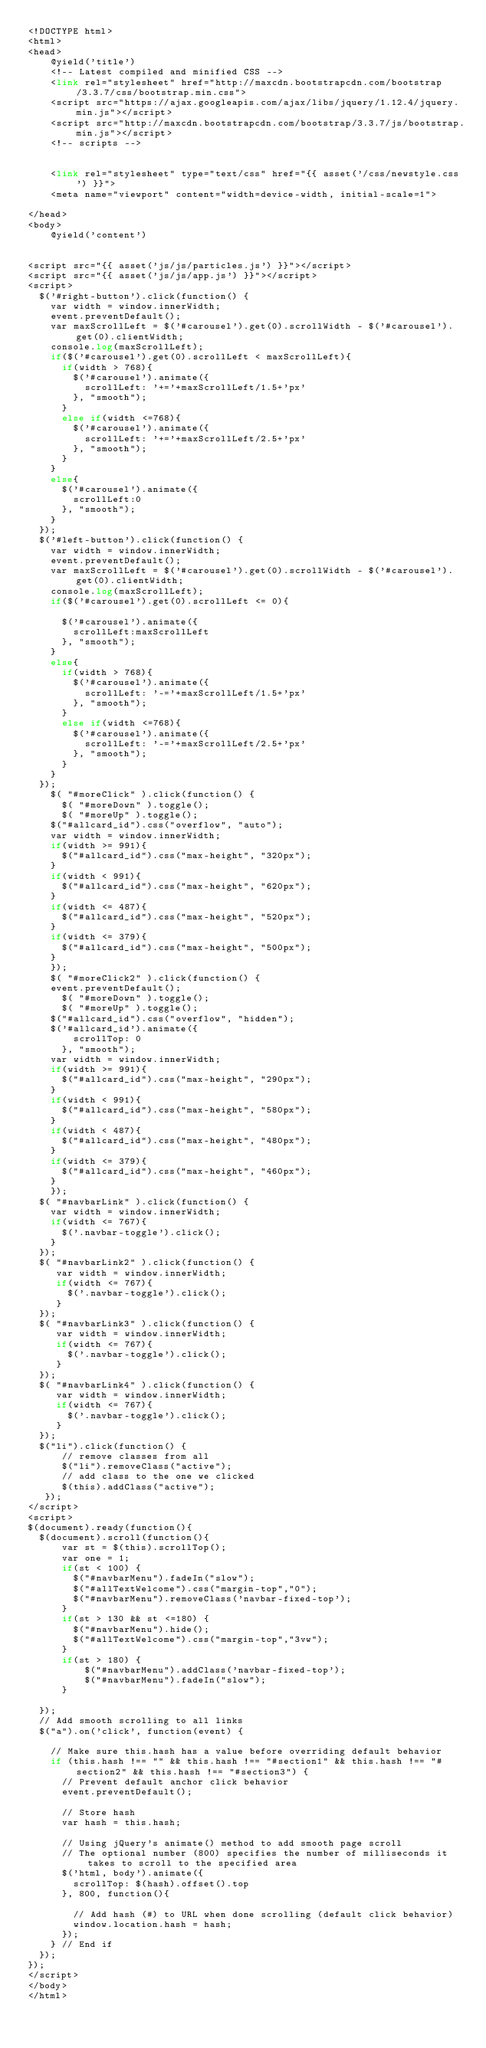Convert code to text. <code><loc_0><loc_0><loc_500><loc_500><_PHP_><!DOCTYPE html>
<html>
<head>
	@yield('title')
	<!-- Latest compiled and minified CSS -->
	<link rel="stylesheet" href="http://maxcdn.bootstrapcdn.com/bootstrap/3.3.7/css/bootstrap.min.css">
  	<script src="https://ajax.googleapis.com/ajax/libs/jquery/1.12.4/jquery.min.js"></script>
  	<script src="http://maxcdn.bootstrapcdn.com/bootstrap/3.3.7/js/bootstrap.min.js"></script>
  	<!-- scripts -->


	<link rel="stylesheet" type="text/css" href="{{ asset('/css/newstyle.css') }}">
	<meta name="viewport" content="width=device-width, initial-scale=1">

</head>
<body>
	@yield('content')


<script src="{{ asset('js/js/particles.js') }}"></script>
<script src="{{ asset('js/js/app.js') }}"></script>
<script>
  $('#right-button').click(function() {
    var width = window.innerWidth;
    event.preventDefault();
    var maxScrollLeft = $('#carousel').get(0).scrollWidth - $('#carousel').get(0).clientWidth;
    console.log(maxScrollLeft);
    if($('#carousel').get(0).scrollLeft < maxScrollLeft){
      if(width > 768){
        $('#carousel').animate({
          scrollLeft: '+='+maxScrollLeft/1.5+'px'
        }, "smooth");
      }
      else if(width <=768){
        $('#carousel').animate({
          scrollLeft: '+='+maxScrollLeft/2.5+'px'
        }, "smooth");
      }
    }
    else{
      $('#carousel').animate({
        scrollLeft:0
      }, "smooth");
    }
  });
  $('#left-button').click(function() {
    var width = window.innerWidth;
    event.preventDefault();
    var maxScrollLeft = $('#carousel').get(0).scrollWidth - $('#carousel').get(0).clientWidth;
    console.log(maxScrollLeft);
    if($('#carousel').get(0).scrollLeft <= 0){
      
      $('#carousel').animate({
        scrollLeft:maxScrollLeft
      }, "smooth");
    }
    else{
      if(width > 768){
        $('#carousel').animate({
          scrollLeft: '-='+maxScrollLeft/1.5+'px'
        }, "smooth");
      }
      else if(width <=768){
        $('#carousel').animate({
          scrollLeft: '-='+maxScrollLeft/2.5+'px'
        }, "smooth");
      }
    }
  });
	$( "#moreClick" ).click(function() {
	  $( "#moreDown" ).toggle();
	  $( "#moreUp" ).toggle();
    $("#allcard_id").css("overflow", "auto");
    var width = window.innerWidth;
    if(width >= 991){ 
      $("#allcard_id").css("max-height", "320px");
    }
    if(width < 991){
      $("#allcard_id").css("max-height", "620px");
    }
    if(width <= 487){
      $("#allcard_id").css("max-height", "520px");
    }
    if(width <= 379){
      $("#allcard_id").css("max-height", "500px");
    }
	});
	$( "#moreClick2" ).click(function() {
    event.preventDefault();
	  $( "#moreDown" ).toggle();
	  $( "#moreUp" ).toggle();
    $("#allcard_id").css("overflow", "hidden");
    $('#allcard_id').animate({
        scrollTop: 0
      }, "smooth");
    var width = window.innerWidth;
    if(width >= 991){ 
      $("#allcard_id").css("max-height", "290px");
    }
    if(width < 991){
      $("#allcard_id").css("max-height", "580px");
    }
    if(width < 487){
      $("#allcard_id").css("max-height", "480px");
    }
    if(width <= 379){
      $("#allcard_id").css("max-height", "460px");
    }
	});
  $( "#navbarLink" ).click(function() {
    var width = window.innerWidth;
    if(width <= 767){ 
      $('.navbar-toggle').click();
    }
  });
  $( "#navbarLink2" ).click(function() {
     var width = window.innerWidth;
     if(width <= 767){ 
       $('.navbar-toggle').click();
     }
  });
  $( "#navbarLink3" ).click(function() {
     var width = window.innerWidth;
     if(width <= 767){ 
       $('.navbar-toggle').click();
     }
  });
  $( "#navbarLink4" ).click(function() {
     var width = window.innerWidth;
     if(width <= 767){ 
       $('.navbar-toggle').click();
     }
  });
  $("li").click(function() {
      // remove classes from all
      $("li").removeClass("active");
      // add class to the one we clicked
      $(this).addClass("active");
   });
</script>
<script>
$(document).ready(function(){
  $(document).scroll(function(){
      var st = $(this).scrollTop();
      var one = 1;
      if(st < 100) {
        $("#navbarMenu").fadeIn("slow");
        $("#allTextWelcome").css("margin-top","0");
        $("#navbarMenu").removeClass('navbar-fixed-top');
      }
      if(st > 130 && st <=180) {
        $("#navbarMenu").hide();
        $("#allTextWelcome").css("margin-top","3vw");
      }
      if(st > 180) {
          $("#navbarMenu").addClass('navbar-fixed-top');
          $("#navbarMenu").fadeIn("slow");
      }

  });
  // Add smooth scrolling to all links
  $("a").on('click', function(event) {

    // Make sure this.hash has a value before overriding default behavior
    if (this.hash !== "" && this.hash !== "#section1" && this.hash !== "#section2" && this.hash !== "#section3") {
      // Prevent default anchor click behavior
      event.preventDefault();

      // Store hash
      var hash = this.hash;

      // Using jQuery's animate() method to add smooth page scroll
      // The optional number (800) specifies the number of milliseconds it takes to scroll to the specified area
      $('html, body').animate({
        scrollTop: $(hash).offset().top
      }, 800, function(){
   
        // Add hash (#) to URL when done scrolling (default click behavior)
        window.location.hash = hash;
      });
    } // End if
  });
});
</script>
</body>
</html>
</code> 